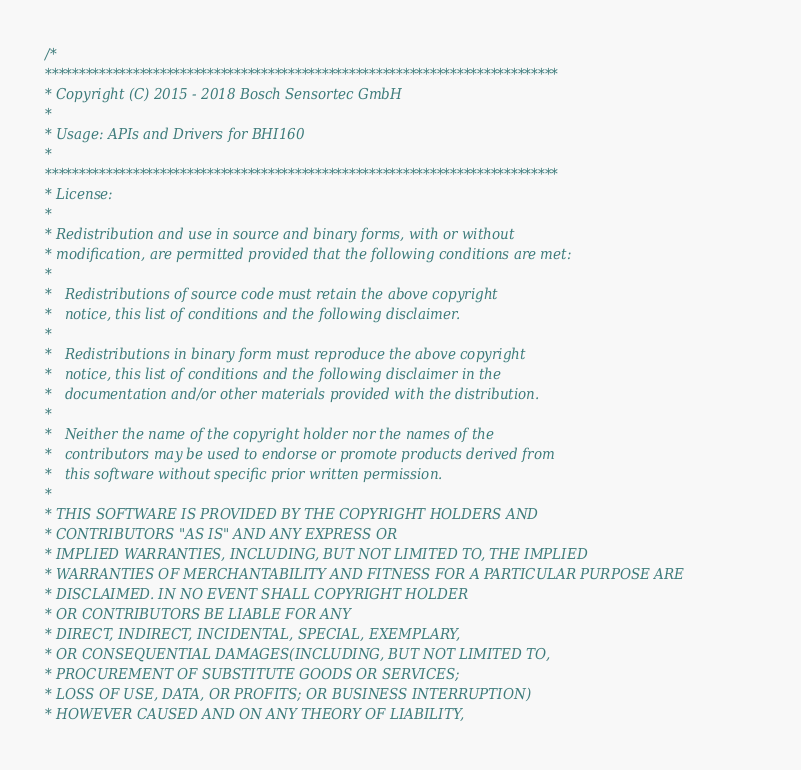<code> <loc_0><loc_0><loc_500><loc_500><_C_>/*
****************************************************************************
* Copyright (C) 2015 - 2018 Bosch Sensortec GmbH
*
* Usage: APIs and Drivers for BHI160
*
****************************************************************************
* License:
*
* Redistribution and use in source and binary forms, with or without
* modification, are permitted provided that the following conditions are met:
*
*   Redistributions of source code must retain the above copyright
*   notice, this list of conditions and the following disclaimer.
*
*   Redistributions in binary form must reproduce the above copyright
*   notice, this list of conditions and the following disclaimer in the
*   documentation and/or other materials provided with the distribution.
*
*   Neither the name of the copyright holder nor the names of the
*   contributors may be used to endorse or promote products derived from
*   this software without specific prior written permission.
*
* THIS SOFTWARE IS PROVIDED BY THE COPYRIGHT HOLDERS AND
* CONTRIBUTORS "AS IS" AND ANY EXPRESS OR
* IMPLIED WARRANTIES, INCLUDING, BUT NOT LIMITED TO, THE IMPLIED
* WARRANTIES OF MERCHANTABILITY AND FITNESS FOR A PARTICULAR PURPOSE ARE
* DISCLAIMED. IN NO EVENT SHALL COPYRIGHT HOLDER
* OR CONTRIBUTORS BE LIABLE FOR ANY
* DIRECT, INDIRECT, INCIDENTAL, SPECIAL, EXEMPLARY,
* OR CONSEQUENTIAL DAMAGES(INCLUDING, BUT NOT LIMITED TO,
* PROCUREMENT OF SUBSTITUTE GOODS OR SERVICES;
* LOSS OF USE, DATA, OR PROFITS; OR BUSINESS INTERRUPTION)
* HOWEVER CAUSED AND ON ANY THEORY OF LIABILITY,</code> 